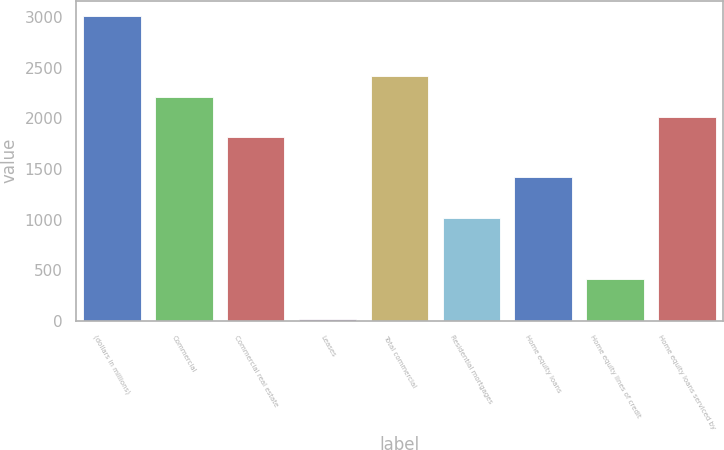<chart> <loc_0><loc_0><loc_500><loc_500><bar_chart><fcel>(dollars in millions)<fcel>Commercial<fcel>Commercial real estate<fcel>Leases<fcel>Total commercial<fcel>Residential mortgages<fcel>Home equity loans<fcel>Home equity lines of credit<fcel>Home equity loans serviced by<nl><fcel>3010<fcel>2212.4<fcel>1813.6<fcel>19<fcel>2411.8<fcel>1016<fcel>1414.8<fcel>417.8<fcel>2013<nl></chart> 